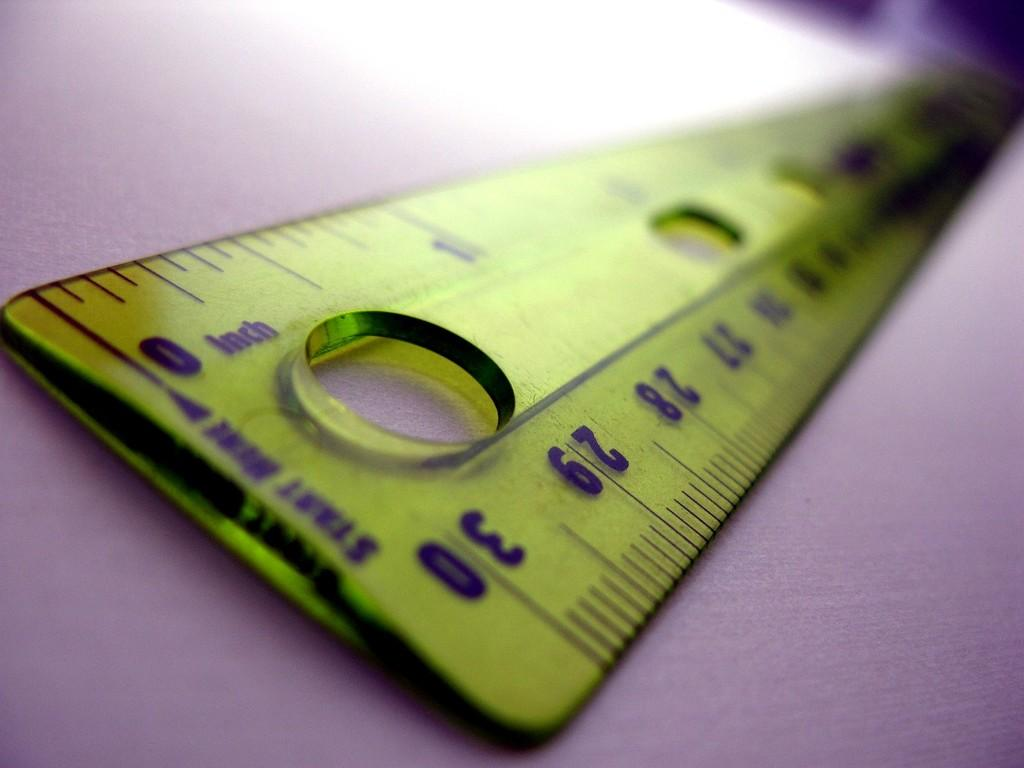Provide a one-sentence caption for the provided image. Ruler that is thirty inches in length it is yellow and purple it is laying on a purple surface. 